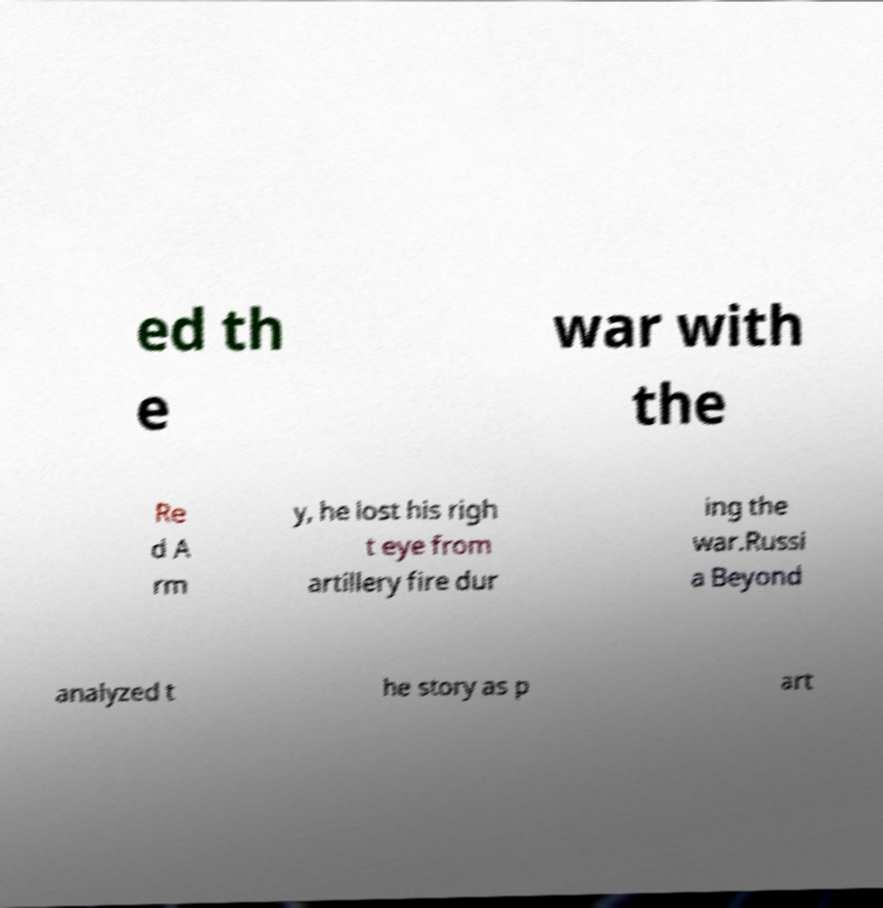Please identify and transcribe the text found in this image. ed th e war with the Re d A rm y, he lost his righ t eye from artillery fire dur ing the war.Russi a Beyond analyzed t he story as p art 